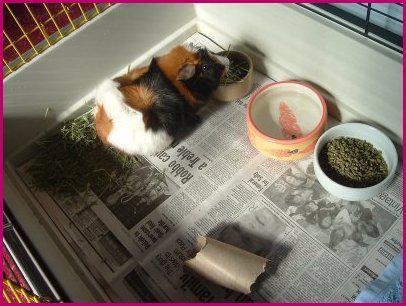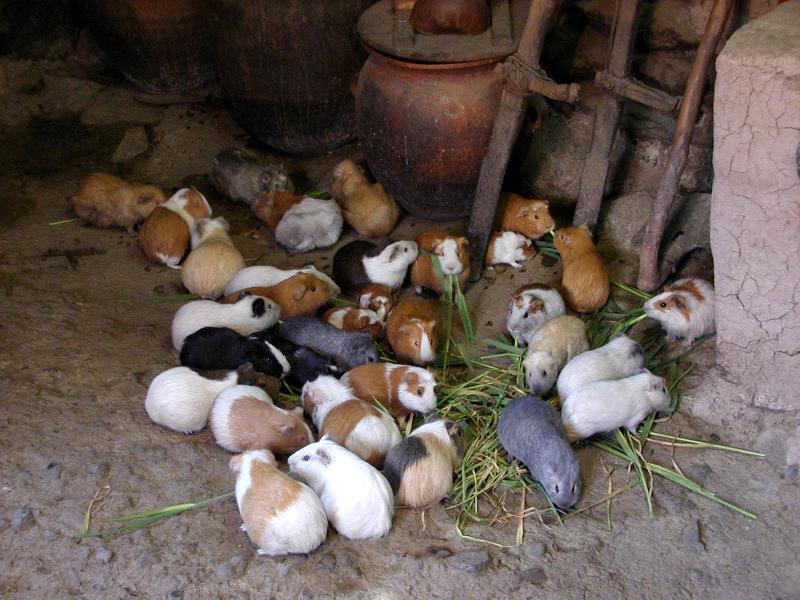The first image is the image on the left, the second image is the image on the right. For the images shown, is this caption "An image shows variously colored hamsters arranged in stepped rows." true? Answer yes or no. No. The first image is the image on the left, the second image is the image on the right. Given the left and right images, does the statement "Some of the animals are sitting on steps outside." hold true? Answer yes or no. No. 